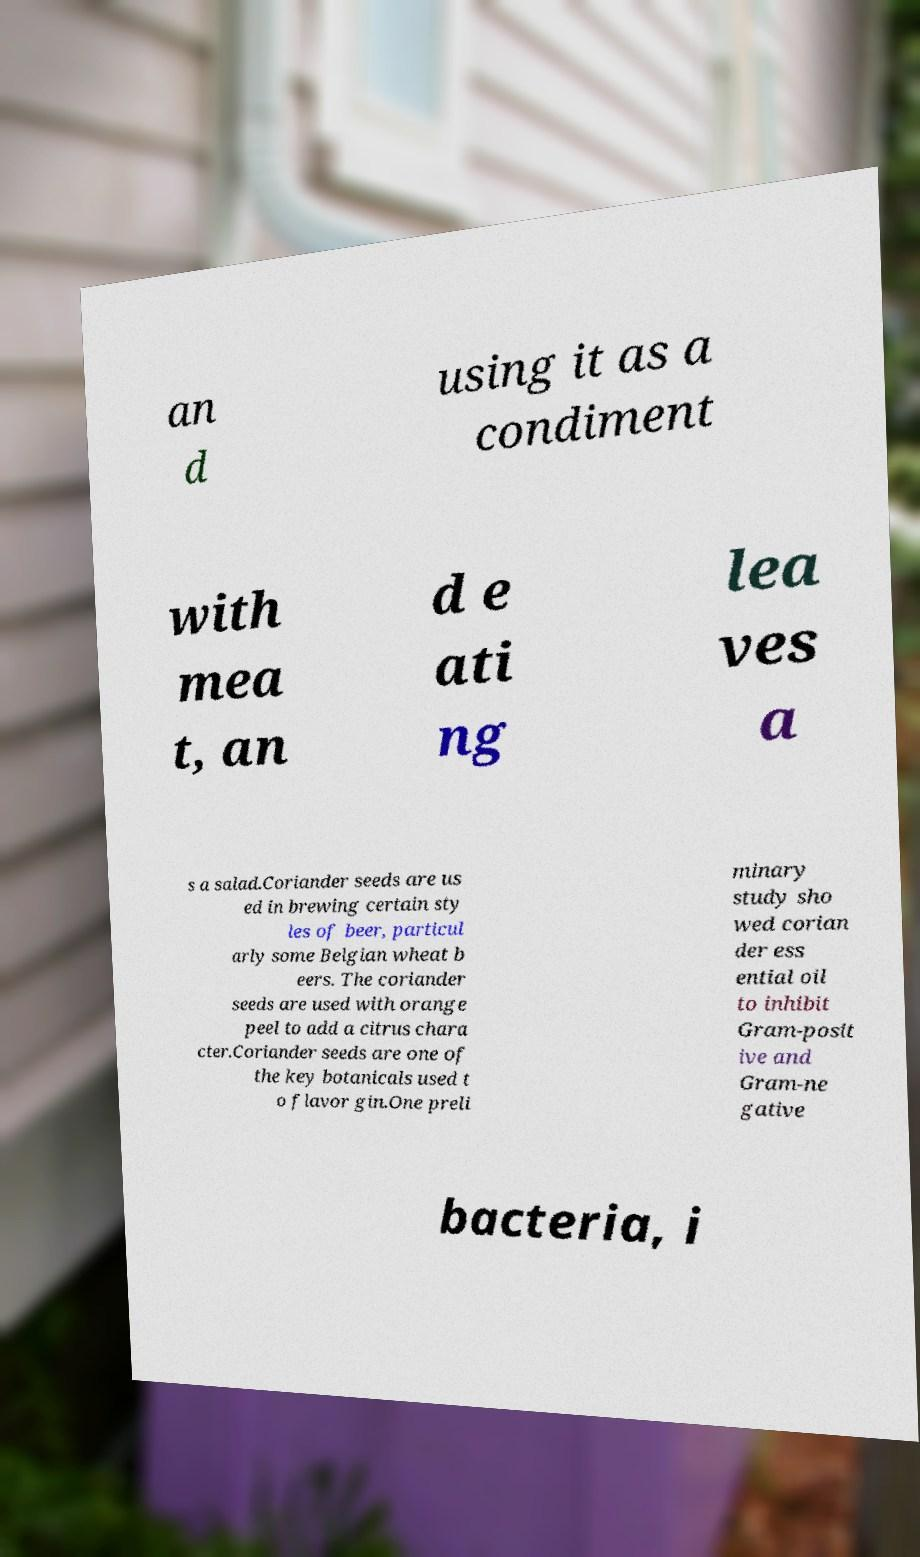What messages or text are displayed in this image? I need them in a readable, typed format. an d using it as a condiment with mea t, an d e ati ng lea ves a s a salad.Coriander seeds are us ed in brewing certain sty les of beer, particul arly some Belgian wheat b eers. The coriander seeds are used with orange peel to add a citrus chara cter.Coriander seeds are one of the key botanicals used t o flavor gin.One preli minary study sho wed corian der ess ential oil to inhibit Gram-posit ive and Gram-ne gative bacteria, i 